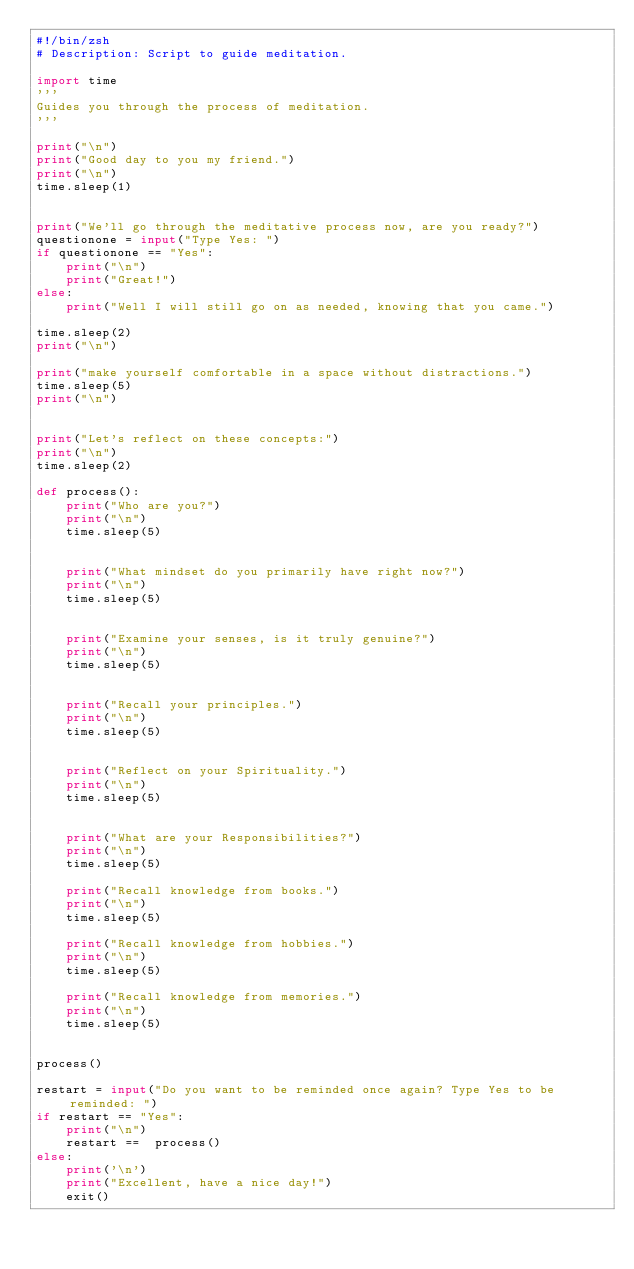<code> <loc_0><loc_0><loc_500><loc_500><_Python_>#!/bin/zsh
# Description: Script to guide meditation.

import time
'''
Guides you through the process of meditation.
'''

print("\n")
print("Good day to you my friend.")
print("\n")
time.sleep(1)


print("We'll go through the meditative process now, are you ready?")
questionone = input("Type Yes: ")
if questionone == "Yes":
    print("\n")
    print("Great!")
else:
    print("Well I will still go on as needed, knowing that you came.")
    
time.sleep(2)
print("\n")

print("make yourself comfortable in a space without distractions.")      
time.sleep(5)
print("\n")


print("Let's reflect on these concepts:")
print("\n")
time.sleep(2)

def process():
    print("Who are you?")
    print("\n")
    time.sleep(5)


    print("What mindset do you primarily have right now?")
    print("\n")
    time.sleep(5)


    print("Examine your senses, is it truly genuine?")
    print("\n")
    time.sleep(5)


    print("Recall your principles.")
    print("\n")
    time.sleep(5)


    print("Reflect on your Spirituality.")
    print("\n")
    time.sleep(5)


    print("What are your Responsibilities?")
    print("\n")
    time.sleep(5)

    print("Recall knowledge from books.")
    print("\n")
    time.sleep(5)

    print("Recall knowledge from hobbies.")
    print("\n")
    time.sleep(5)

    print("Recall knowledge from memories.")
    print("\n")
    time.sleep(5)

    
process()

restart = input("Do you want to be reminded once again? Type Yes to be reminded: ")
if restart == "Yes":
    print("\n")
    restart ==  process()
else:
    print('\n')
    print("Excellent, have a nice day!")
    exit()


</code> 